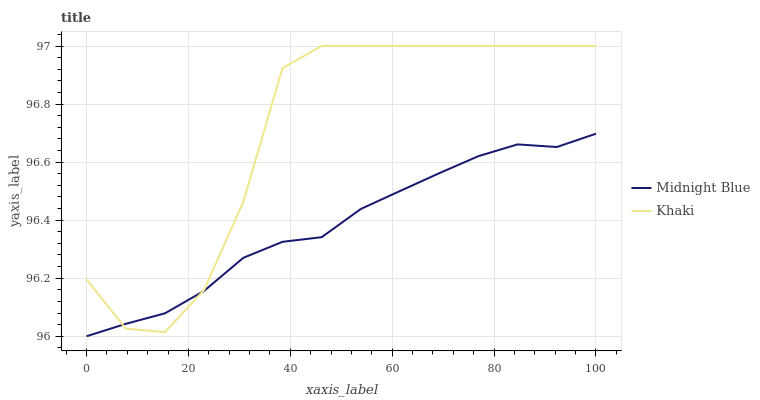Does Midnight Blue have the maximum area under the curve?
Answer yes or no. No. Is Midnight Blue the roughest?
Answer yes or no. No. Does Midnight Blue have the highest value?
Answer yes or no. No. 